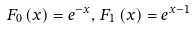<formula> <loc_0><loc_0><loc_500><loc_500>F _ { 0 } \left ( x \right ) = e ^ { - x } , \, F _ { 1 } \left ( x \right ) = e ^ { x - 1 }</formula> 